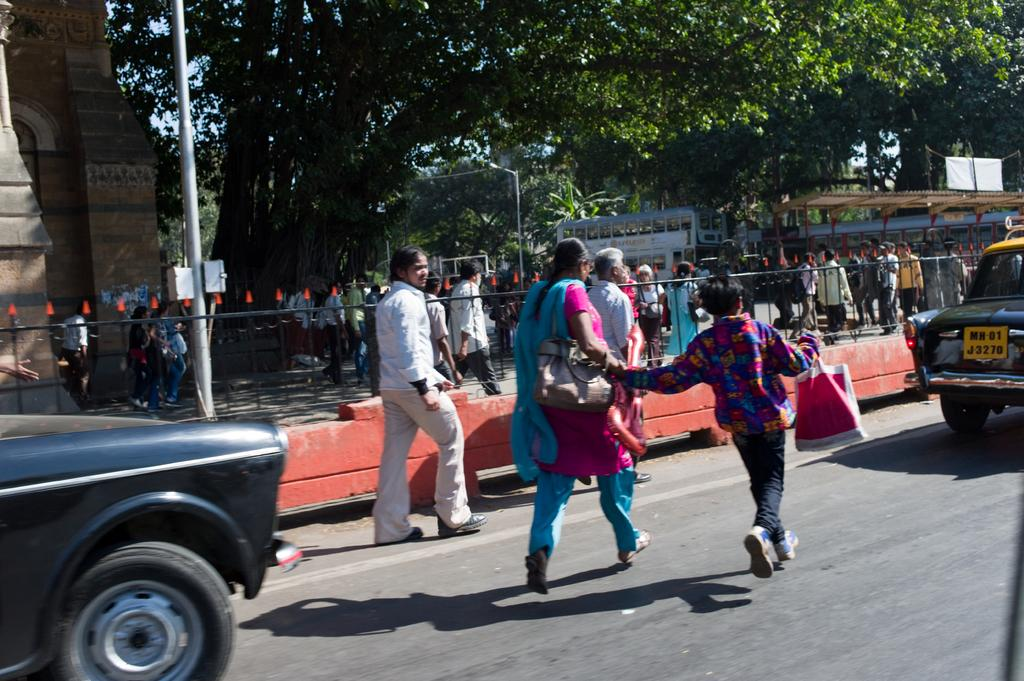What are the people in the image doing? The people in the image are standing on the road. What else can be seen on the road? There are vehicles parked on the road. What can be seen in the distance in the image? There are trees visible in the background. How many eggs are being used to pave the road in the image? There are no eggs present in the image, and eggs are not used to pave roads. 